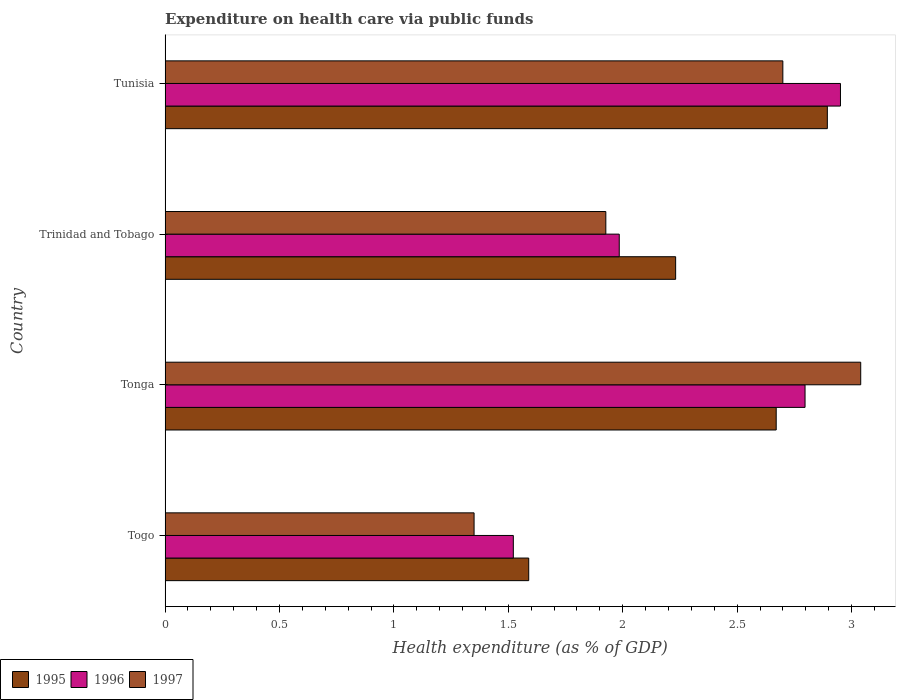How many different coloured bars are there?
Offer a very short reply. 3. Are the number of bars per tick equal to the number of legend labels?
Provide a short and direct response. Yes. How many bars are there on the 1st tick from the top?
Make the answer very short. 3. What is the label of the 4th group of bars from the top?
Make the answer very short. Togo. In how many cases, is the number of bars for a given country not equal to the number of legend labels?
Ensure brevity in your answer.  0. What is the expenditure made on health care in 1995 in Trinidad and Tobago?
Provide a succinct answer. 2.23. Across all countries, what is the maximum expenditure made on health care in 1997?
Give a very brief answer. 3.04. Across all countries, what is the minimum expenditure made on health care in 1996?
Ensure brevity in your answer.  1.52. In which country was the expenditure made on health care in 1995 maximum?
Your answer should be very brief. Tunisia. In which country was the expenditure made on health care in 1995 minimum?
Give a very brief answer. Togo. What is the total expenditure made on health care in 1997 in the graph?
Provide a succinct answer. 9.02. What is the difference between the expenditure made on health care in 1997 in Togo and that in Tonga?
Give a very brief answer. -1.69. What is the difference between the expenditure made on health care in 1996 in Tonga and the expenditure made on health care in 1995 in Tunisia?
Provide a short and direct response. -0.1. What is the average expenditure made on health care in 1995 per country?
Offer a terse response. 2.35. What is the difference between the expenditure made on health care in 1996 and expenditure made on health care in 1997 in Tonga?
Provide a short and direct response. -0.24. What is the ratio of the expenditure made on health care in 1996 in Togo to that in Tonga?
Ensure brevity in your answer.  0.54. Is the difference between the expenditure made on health care in 1996 in Togo and Tonga greater than the difference between the expenditure made on health care in 1997 in Togo and Tonga?
Offer a very short reply. Yes. What is the difference between the highest and the second highest expenditure made on health care in 1995?
Your answer should be very brief. 0.22. What is the difference between the highest and the lowest expenditure made on health care in 1996?
Ensure brevity in your answer.  1.43. In how many countries, is the expenditure made on health care in 1995 greater than the average expenditure made on health care in 1995 taken over all countries?
Ensure brevity in your answer.  2. Is the sum of the expenditure made on health care in 1995 in Togo and Trinidad and Tobago greater than the maximum expenditure made on health care in 1996 across all countries?
Your answer should be very brief. Yes. What does the 3rd bar from the top in Trinidad and Tobago represents?
Provide a succinct answer. 1995. How many bars are there?
Your answer should be compact. 12. How many countries are there in the graph?
Provide a succinct answer. 4. Are the values on the major ticks of X-axis written in scientific E-notation?
Ensure brevity in your answer.  No. Does the graph contain any zero values?
Provide a succinct answer. No. What is the title of the graph?
Provide a short and direct response. Expenditure on health care via public funds. What is the label or title of the X-axis?
Give a very brief answer. Health expenditure (as % of GDP). What is the label or title of the Y-axis?
Provide a succinct answer. Country. What is the Health expenditure (as % of GDP) in 1995 in Togo?
Make the answer very short. 1.59. What is the Health expenditure (as % of GDP) of 1996 in Togo?
Offer a terse response. 1.52. What is the Health expenditure (as % of GDP) of 1997 in Togo?
Provide a short and direct response. 1.35. What is the Health expenditure (as % of GDP) of 1995 in Tonga?
Ensure brevity in your answer.  2.67. What is the Health expenditure (as % of GDP) of 1996 in Tonga?
Offer a terse response. 2.8. What is the Health expenditure (as % of GDP) in 1997 in Tonga?
Keep it short and to the point. 3.04. What is the Health expenditure (as % of GDP) of 1995 in Trinidad and Tobago?
Provide a succinct answer. 2.23. What is the Health expenditure (as % of GDP) in 1996 in Trinidad and Tobago?
Make the answer very short. 1.98. What is the Health expenditure (as % of GDP) in 1997 in Trinidad and Tobago?
Keep it short and to the point. 1.93. What is the Health expenditure (as % of GDP) in 1995 in Tunisia?
Offer a very short reply. 2.89. What is the Health expenditure (as % of GDP) in 1996 in Tunisia?
Provide a short and direct response. 2.95. What is the Health expenditure (as % of GDP) of 1997 in Tunisia?
Your answer should be very brief. 2.7. Across all countries, what is the maximum Health expenditure (as % of GDP) in 1995?
Provide a succinct answer. 2.89. Across all countries, what is the maximum Health expenditure (as % of GDP) of 1996?
Keep it short and to the point. 2.95. Across all countries, what is the maximum Health expenditure (as % of GDP) of 1997?
Your response must be concise. 3.04. Across all countries, what is the minimum Health expenditure (as % of GDP) in 1995?
Make the answer very short. 1.59. Across all countries, what is the minimum Health expenditure (as % of GDP) of 1996?
Provide a succinct answer. 1.52. Across all countries, what is the minimum Health expenditure (as % of GDP) in 1997?
Offer a terse response. 1.35. What is the total Health expenditure (as % of GDP) of 1995 in the graph?
Offer a very short reply. 9.39. What is the total Health expenditure (as % of GDP) of 1996 in the graph?
Ensure brevity in your answer.  9.26. What is the total Health expenditure (as % of GDP) of 1997 in the graph?
Provide a short and direct response. 9.02. What is the difference between the Health expenditure (as % of GDP) in 1995 in Togo and that in Tonga?
Ensure brevity in your answer.  -1.08. What is the difference between the Health expenditure (as % of GDP) in 1996 in Togo and that in Tonga?
Give a very brief answer. -1.27. What is the difference between the Health expenditure (as % of GDP) in 1997 in Togo and that in Tonga?
Your response must be concise. -1.69. What is the difference between the Health expenditure (as % of GDP) of 1995 in Togo and that in Trinidad and Tobago?
Ensure brevity in your answer.  -0.64. What is the difference between the Health expenditure (as % of GDP) in 1996 in Togo and that in Trinidad and Tobago?
Keep it short and to the point. -0.46. What is the difference between the Health expenditure (as % of GDP) in 1997 in Togo and that in Trinidad and Tobago?
Keep it short and to the point. -0.58. What is the difference between the Health expenditure (as % of GDP) of 1995 in Togo and that in Tunisia?
Provide a short and direct response. -1.31. What is the difference between the Health expenditure (as % of GDP) in 1996 in Togo and that in Tunisia?
Ensure brevity in your answer.  -1.43. What is the difference between the Health expenditure (as % of GDP) in 1997 in Togo and that in Tunisia?
Your response must be concise. -1.35. What is the difference between the Health expenditure (as % of GDP) in 1995 in Tonga and that in Trinidad and Tobago?
Your answer should be very brief. 0.44. What is the difference between the Health expenditure (as % of GDP) of 1996 in Tonga and that in Trinidad and Tobago?
Your answer should be compact. 0.81. What is the difference between the Health expenditure (as % of GDP) in 1997 in Tonga and that in Trinidad and Tobago?
Ensure brevity in your answer.  1.11. What is the difference between the Health expenditure (as % of GDP) in 1995 in Tonga and that in Tunisia?
Offer a very short reply. -0.22. What is the difference between the Health expenditure (as % of GDP) of 1996 in Tonga and that in Tunisia?
Your answer should be very brief. -0.15. What is the difference between the Health expenditure (as % of GDP) in 1997 in Tonga and that in Tunisia?
Provide a succinct answer. 0.34. What is the difference between the Health expenditure (as % of GDP) in 1995 in Trinidad and Tobago and that in Tunisia?
Your response must be concise. -0.66. What is the difference between the Health expenditure (as % of GDP) in 1996 in Trinidad and Tobago and that in Tunisia?
Give a very brief answer. -0.97. What is the difference between the Health expenditure (as % of GDP) of 1997 in Trinidad and Tobago and that in Tunisia?
Your response must be concise. -0.77. What is the difference between the Health expenditure (as % of GDP) in 1995 in Togo and the Health expenditure (as % of GDP) in 1996 in Tonga?
Give a very brief answer. -1.21. What is the difference between the Health expenditure (as % of GDP) of 1995 in Togo and the Health expenditure (as % of GDP) of 1997 in Tonga?
Make the answer very short. -1.45. What is the difference between the Health expenditure (as % of GDP) of 1996 in Togo and the Health expenditure (as % of GDP) of 1997 in Tonga?
Keep it short and to the point. -1.52. What is the difference between the Health expenditure (as % of GDP) in 1995 in Togo and the Health expenditure (as % of GDP) in 1996 in Trinidad and Tobago?
Offer a very short reply. -0.4. What is the difference between the Health expenditure (as % of GDP) of 1995 in Togo and the Health expenditure (as % of GDP) of 1997 in Trinidad and Tobago?
Ensure brevity in your answer.  -0.34. What is the difference between the Health expenditure (as % of GDP) in 1996 in Togo and the Health expenditure (as % of GDP) in 1997 in Trinidad and Tobago?
Your response must be concise. -0.4. What is the difference between the Health expenditure (as % of GDP) in 1995 in Togo and the Health expenditure (as % of GDP) in 1996 in Tunisia?
Your answer should be very brief. -1.36. What is the difference between the Health expenditure (as % of GDP) of 1995 in Togo and the Health expenditure (as % of GDP) of 1997 in Tunisia?
Ensure brevity in your answer.  -1.11. What is the difference between the Health expenditure (as % of GDP) of 1996 in Togo and the Health expenditure (as % of GDP) of 1997 in Tunisia?
Make the answer very short. -1.18. What is the difference between the Health expenditure (as % of GDP) of 1995 in Tonga and the Health expenditure (as % of GDP) of 1996 in Trinidad and Tobago?
Keep it short and to the point. 0.69. What is the difference between the Health expenditure (as % of GDP) of 1995 in Tonga and the Health expenditure (as % of GDP) of 1997 in Trinidad and Tobago?
Give a very brief answer. 0.74. What is the difference between the Health expenditure (as % of GDP) in 1996 in Tonga and the Health expenditure (as % of GDP) in 1997 in Trinidad and Tobago?
Ensure brevity in your answer.  0.87. What is the difference between the Health expenditure (as % of GDP) of 1995 in Tonga and the Health expenditure (as % of GDP) of 1996 in Tunisia?
Give a very brief answer. -0.28. What is the difference between the Health expenditure (as % of GDP) in 1995 in Tonga and the Health expenditure (as % of GDP) in 1997 in Tunisia?
Your response must be concise. -0.03. What is the difference between the Health expenditure (as % of GDP) in 1996 in Tonga and the Health expenditure (as % of GDP) in 1997 in Tunisia?
Your answer should be very brief. 0.1. What is the difference between the Health expenditure (as % of GDP) of 1995 in Trinidad and Tobago and the Health expenditure (as % of GDP) of 1996 in Tunisia?
Offer a terse response. -0.72. What is the difference between the Health expenditure (as % of GDP) in 1995 in Trinidad and Tobago and the Health expenditure (as % of GDP) in 1997 in Tunisia?
Make the answer very short. -0.47. What is the difference between the Health expenditure (as % of GDP) of 1996 in Trinidad and Tobago and the Health expenditure (as % of GDP) of 1997 in Tunisia?
Your answer should be compact. -0.71. What is the average Health expenditure (as % of GDP) in 1995 per country?
Ensure brevity in your answer.  2.35. What is the average Health expenditure (as % of GDP) of 1996 per country?
Provide a succinct answer. 2.31. What is the average Health expenditure (as % of GDP) of 1997 per country?
Make the answer very short. 2.25. What is the difference between the Health expenditure (as % of GDP) in 1995 and Health expenditure (as % of GDP) in 1996 in Togo?
Offer a terse response. 0.07. What is the difference between the Health expenditure (as % of GDP) of 1995 and Health expenditure (as % of GDP) of 1997 in Togo?
Offer a terse response. 0.24. What is the difference between the Health expenditure (as % of GDP) of 1996 and Health expenditure (as % of GDP) of 1997 in Togo?
Offer a terse response. 0.17. What is the difference between the Health expenditure (as % of GDP) in 1995 and Health expenditure (as % of GDP) in 1996 in Tonga?
Your response must be concise. -0.13. What is the difference between the Health expenditure (as % of GDP) in 1995 and Health expenditure (as % of GDP) in 1997 in Tonga?
Provide a short and direct response. -0.37. What is the difference between the Health expenditure (as % of GDP) of 1996 and Health expenditure (as % of GDP) of 1997 in Tonga?
Offer a very short reply. -0.24. What is the difference between the Health expenditure (as % of GDP) in 1995 and Health expenditure (as % of GDP) in 1996 in Trinidad and Tobago?
Offer a terse response. 0.25. What is the difference between the Health expenditure (as % of GDP) of 1995 and Health expenditure (as % of GDP) of 1997 in Trinidad and Tobago?
Offer a very short reply. 0.31. What is the difference between the Health expenditure (as % of GDP) of 1996 and Health expenditure (as % of GDP) of 1997 in Trinidad and Tobago?
Provide a succinct answer. 0.06. What is the difference between the Health expenditure (as % of GDP) of 1995 and Health expenditure (as % of GDP) of 1996 in Tunisia?
Ensure brevity in your answer.  -0.06. What is the difference between the Health expenditure (as % of GDP) of 1995 and Health expenditure (as % of GDP) of 1997 in Tunisia?
Make the answer very short. 0.19. What is the difference between the Health expenditure (as % of GDP) in 1996 and Health expenditure (as % of GDP) in 1997 in Tunisia?
Provide a succinct answer. 0.25. What is the ratio of the Health expenditure (as % of GDP) in 1995 in Togo to that in Tonga?
Provide a short and direct response. 0.59. What is the ratio of the Health expenditure (as % of GDP) in 1996 in Togo to that in Tonga?
Offer a very short reply. 0.54. What is the ratio of the Health expenditure (as % of GDP) in 1997 in Togo to that in Tonga?
Provide a succinct answer. 0.44. What is the ratio of the Health expenditure (as % of GDP) of 1995 in Togo to that in Trinidad and Tobago?
Your answer should be very brief. 0.71. What is the ratio of the Health expenditure (as % of GDP) in 1996 in Togo to that in Trinidad and Tobago?
Keep it short and to the point. 0.77. What is the ratio of the Health expenditure (as % of GDP) in 1997 in Togo to that in Trinidad and Tobago?
Ensure brevity in your answer.  0.7. What is the ratio of the Health expenditure (as % of GDP) of 1995 in Togo to that in Tunisia?
Offer a terse response. 0.55. What is the ratio of the Health expenditure (as % of GDP) of 1996 in Togo to that in Tunisia?
Your response must be concise. 0.52. What is the ratio of the Health expenditure (as % of GDP) in 1997 in Togo to that in Tunisia?
Give a very brief answer. 0.5. What is the ratio of the Health expenditure (as % of GDP) in 1995 in Tonga to that in Trinidad and Tobago?
Provide a short and direct response. 1.2. What is the ratio of the Health expenditure (as % of GDP) of 1996 in Tonga to that in Trinidad and Tobago?
Your response must be concise. 1.41. What is the ratio of the Health expenditure (as % of GDP) of 1997 in Tonga to that in Trinidad and Tobago?
Ensure brevity in your answer.  1.58. What is the ratio of the Health expenditure (as % of GDP) of 1995 in Tonga to that in Tunisia?
Make the answer very short. 0.92. What is the ratio of the Health expenditure (as % of GDP) in 1996 in Tonga to that in Tunisia?
Offer a very short reply. 0.95. What is the ratio of the Health expenditure (as % of GDP) of 1997 in Tonga to that in Tunisia?
Make the answer very short. 1.13. What is the ratio of the Health expenditure (as % of GDP) in 1995 in Trinidad and Tobago to that in Tunisia?
Your response must be concise. 0.77. What is the ratio of the Health expenditure (as % of GDP) in 1996 in Trinidad and Tobago to that in Tunisia?
Your answer should be compact. 0.67. What is the ratio of the Health expenditure (as % of GDP) in 1997 in Trinidad and Tobago to that in Tunisia?
Keep it short and to the point. 0.71. What is the difference between the highest and the second highest Health expenditure (as % of GDP) in 1995?
Provide a succinct answer. 0.22. What is the difference between the highest and the second highest Health expenditure (as % of GDP) in 1996?
Make the answer very short. 0.15. What is the difference between the highest and the second highest Health expenditure (as % of GDP) of 1997?
Your answer should be compact. 0.34. What is the difference between the highest and the lowest Health expenditure (as % of GDP) of 1995?
Your answer should be compact. 1.31. What is the difference between the highest and the lowest Health expenditure (as % of GDP) in 1996?
Give a very brief answer. 1.43. What is the difference between the highest and the lowest Health expenditure (as % of GDP) in 1997?
Keep it short and to the point. 1.69. 